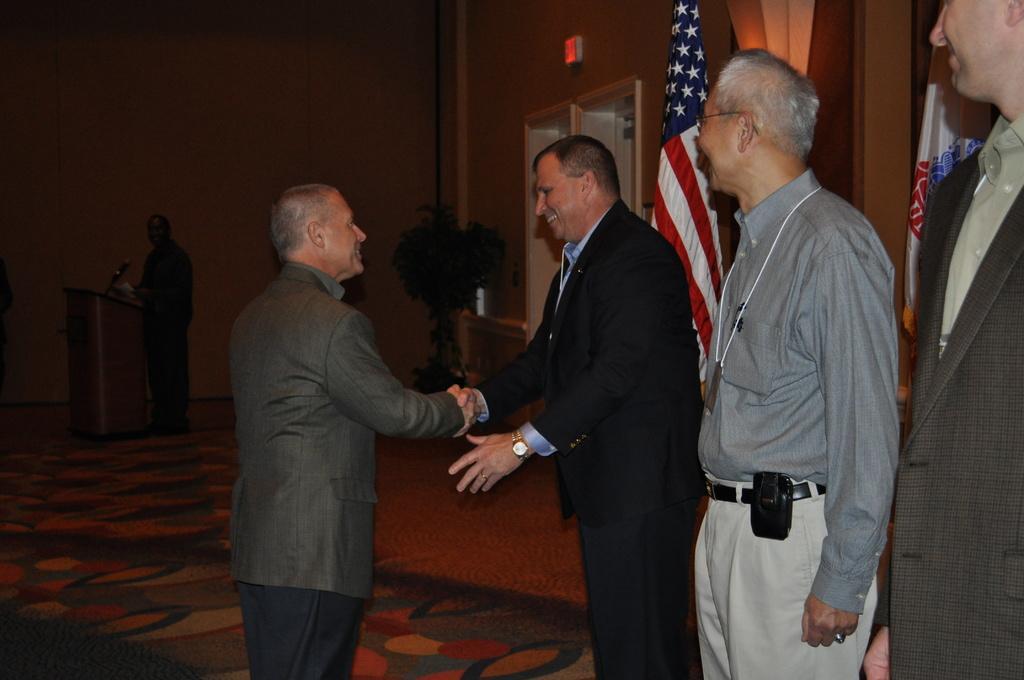In one or two sentences, can you explain what this image depicts? In this image I can see a person wearing black colored dress and another person wearing grey colored jacket are standing and shaking hands. I can see two other persons standing. In the background I can see the wall, a plant, the door, a person is standing in front of the podium and the exit board to the wall. 